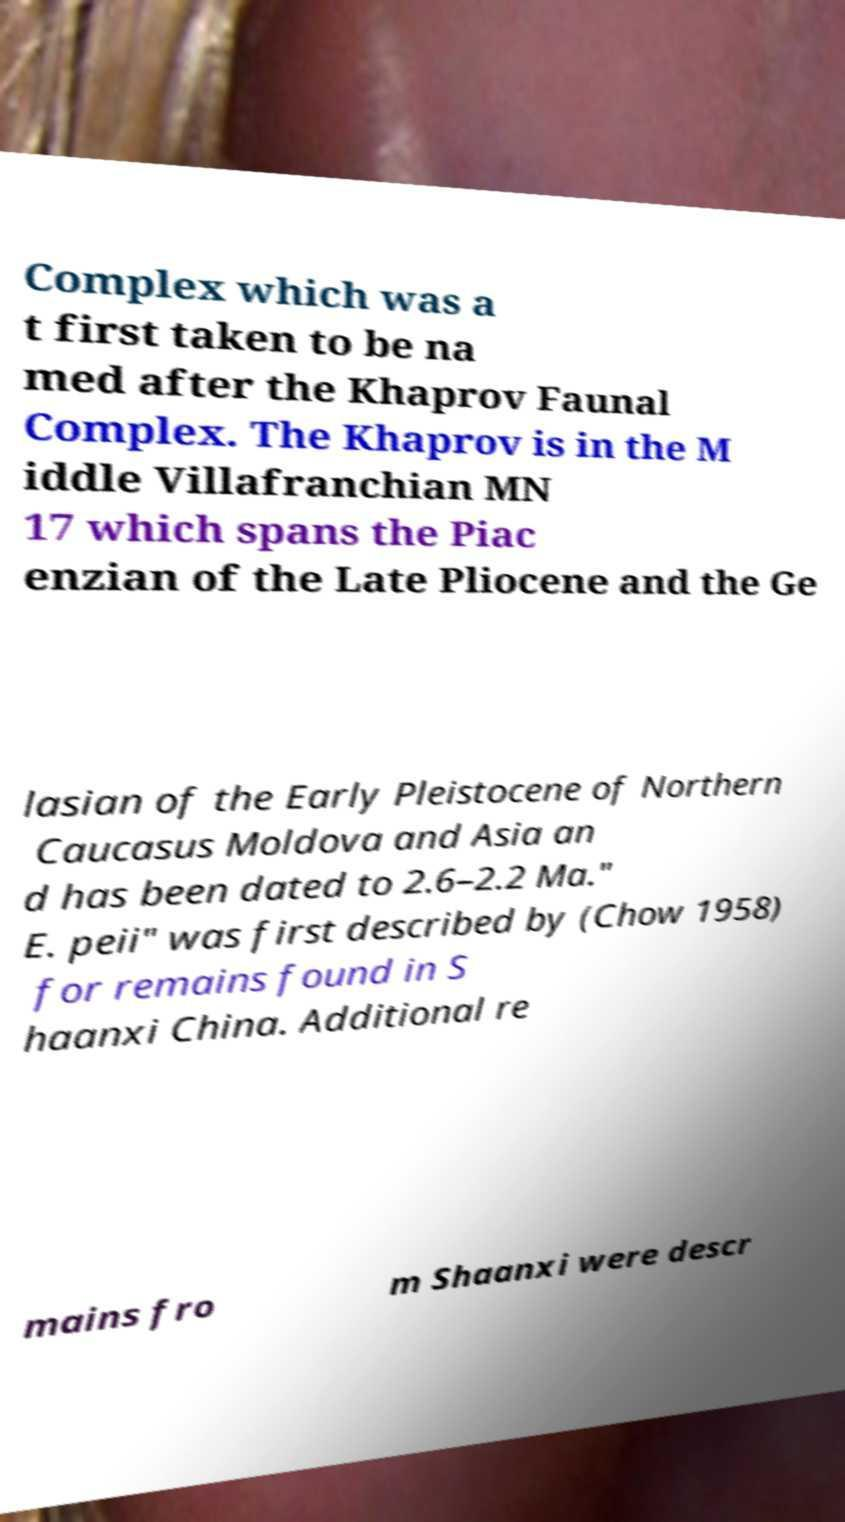Could you extract and type out the text from this image? Complex which was a t first taken to be na med after the Khaprov Faunal Complex. The Khaprov is in the M iddle Villafranchian MN 17 which spans the Piac enzian of the Late Pliocene and the Ge lasian of the Early Pleistocene of Northern Caucasus Moldova and Asia an d has been dated to 2.6–2.2 Ma." E. peii" was first described by (Chow 1958) for remains found in S haanxi China. Additional re mains fro m Shaanxi were descr 